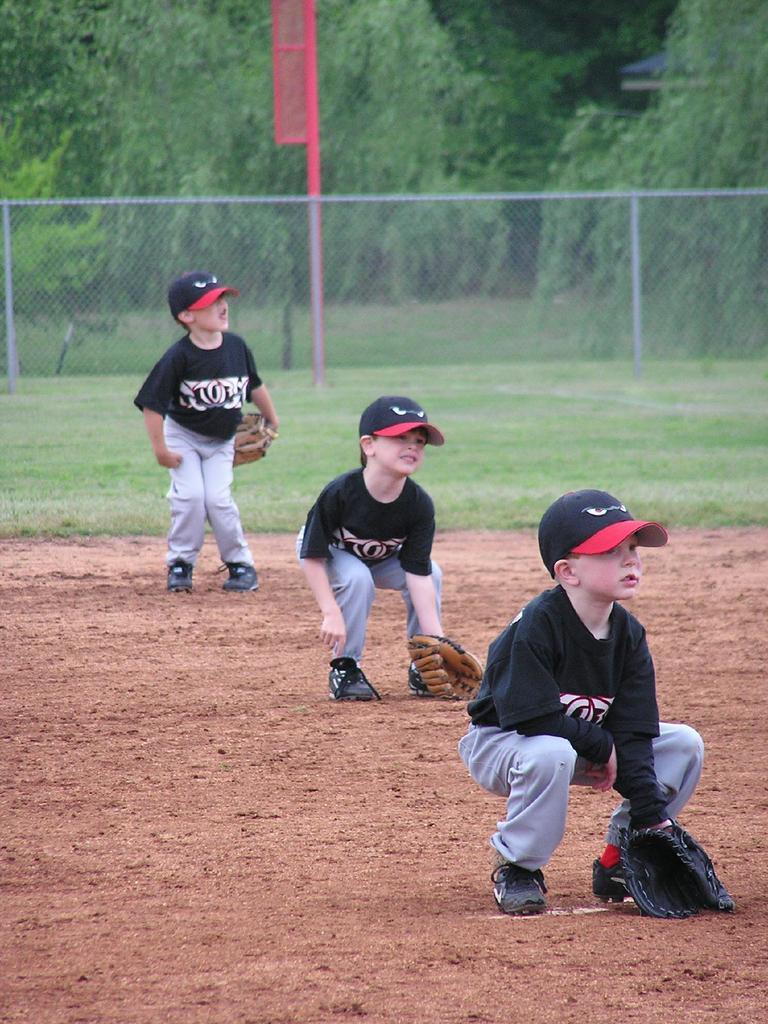Please provide a concise description of this image. In this image I can see three people with black and ash color dresses. I can see these people with caps and gloves. In the background I can see the net fence, poles and many trees. 